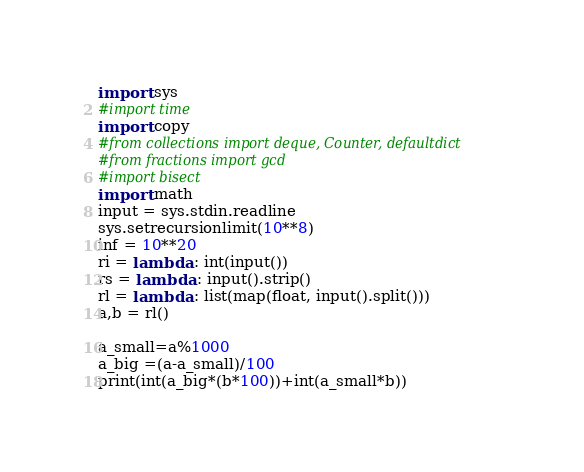Convert code to text. <code><loc_0><loc_0><loc_500><loc_500><_Python_>import sys
#import time
import copy
#from collections import deque, Counter, defaultdict
#from fractions import gcd
#import bisect
import math
input = sys.stdin.readline
sys.setrecursionlimit(10**8)
inf = 10**20
ri = lambda : int(input())
rs = lambda : input().strip()
rl = lambda : list(map(float, input().split()))
a,b = rl()

a_small=a%1000
a_big =(a-a_small)/100
print(int(a_big*(b*100))+int(a_small*b))</code> 